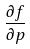<formula> <loc_0><loc_0><loc_500><loc_500>\frac { \partial f } { \partial p }</formula> 